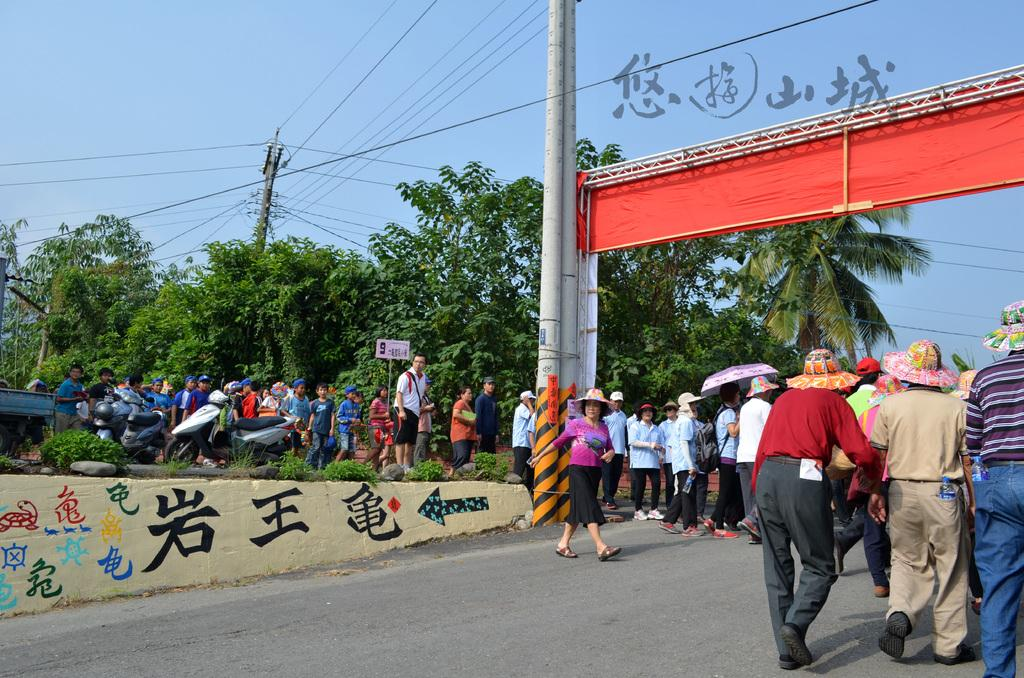What are the people in the image doing? There are persons walking on the road in the image. What structures can be seen in the image? Electric poles are present in the image. What is connected to the electric poles? Electric cables are visible in the image. What type of vegetation is present in the image? There are trees in the image. What is visible in the background of the image? The sky is visible in the image. What type of dinner is being prepared in the image? There is no indication of dinner preparation in the image; it primarily features persons walking on the road and various structures and vegetation. 